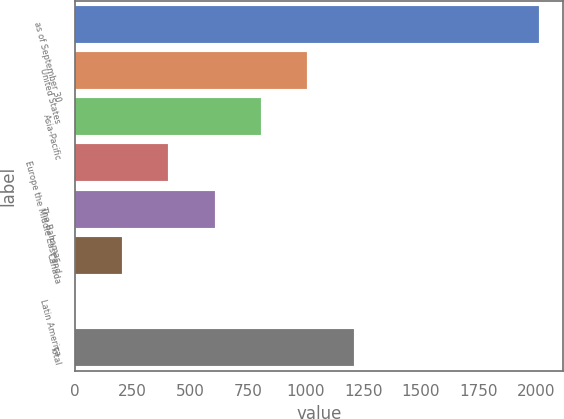Convert chart to OTSL. <chart><loc_0><loc_0><loc_500><loc_500><bar_chart><fcel>as of September 30<fcel>United States<fcel>Asia-Pacific<fcel>Europe the Middle East and<fcel>The Bahamas<fcel>Canada<fcel>Latin America<fcel>Total<nl><fcel>2013<fcel>1006.8<fcel>805.56<fcel>403.08<fcel>604.32<fcel>201.84<fcel>0.6<fcel>1208.04<nl></chart> 